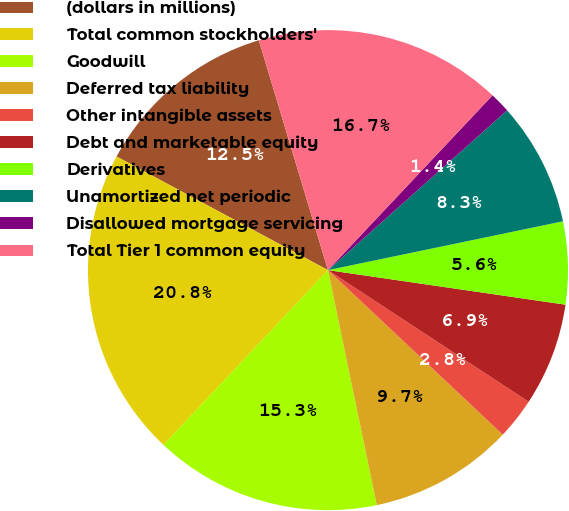<chart> <loc_0><loc_0><loc_500><loc_500><pie_chart><fcel>(dollars in millions)<fcel>Total common stockholders'<fcel>Goodwill<fcel>Deferred tax liability<fcel>Other intangible assets<fcel>Debt and marketable equity<fcel>Derivatives<fcel>Unamortized net periodic<fcel>Disallowed mortgage servicing<fcel>Total Tier 1 common equity<nl><fcel>12.5%<fcel>20.83%<fcel>15.28%<fcel>9.72%<fcel>2.78%<fcel>6.94%<fcel>5.56%<fcel>8.33%<fcel>1.39%<fcel>16.67%<nl></chart> 